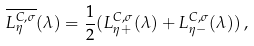Convert formula to latex. <formula><loc_0><loc_0><loc_500><loc_500>\overline { L ^ { C , \sigma } _ { \eta } } ( \lambda ) = \frac { 1 } { 2 } ( L ^ { C , \sigma } _ { \eta + } ( \lambda ) + L ^ { C , \sigma } _ { \eta - } ( \lambda ) ) \, ,</formula> 